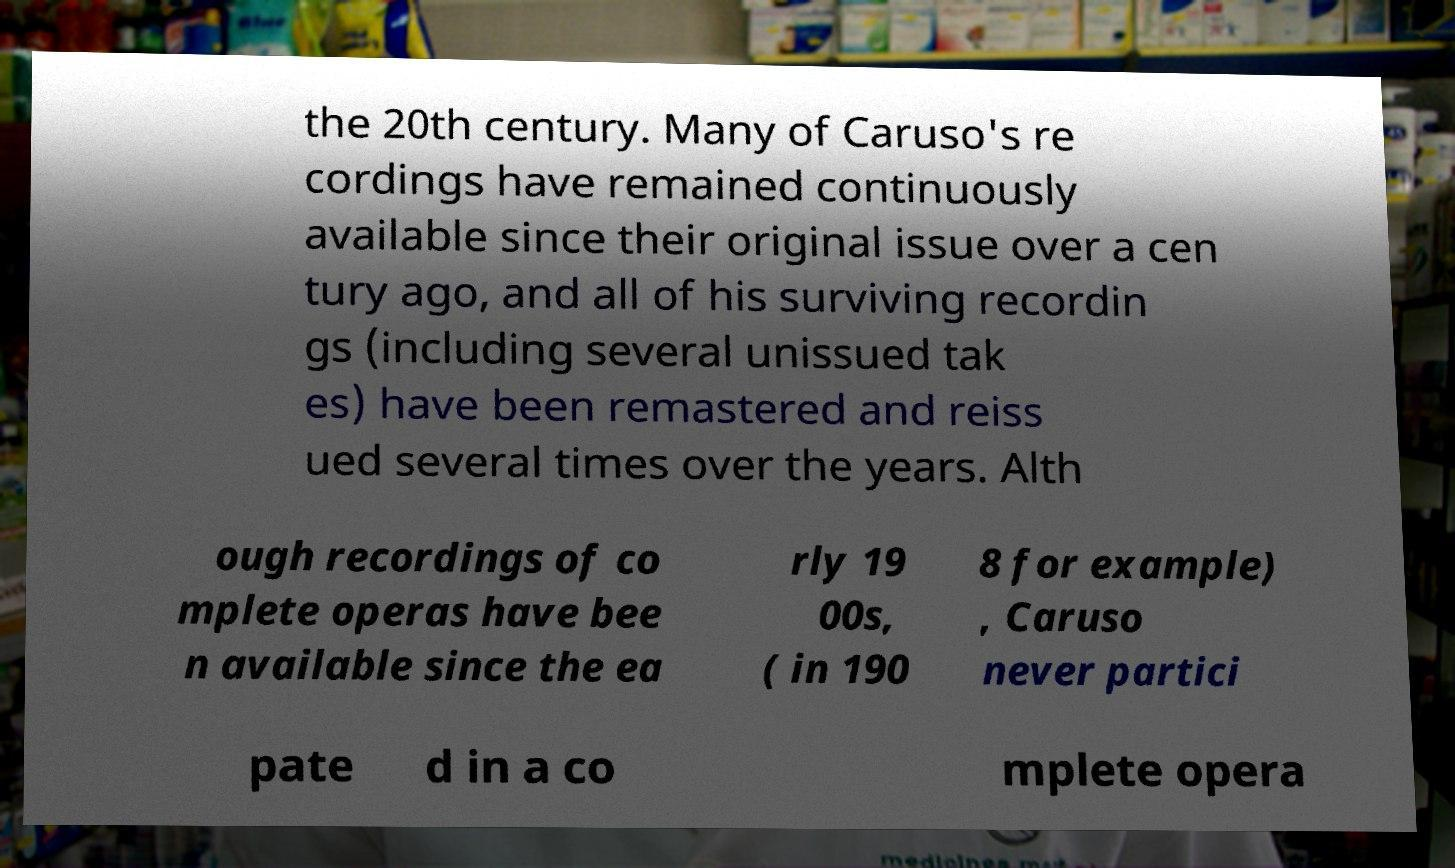There's text embedded in this image that I need extracted. Can you transcribe it verbatim? the 20th century. Many of Caruso's re cordings have remained continuously available since their original issue over a cen tury ago, and all of his surviving recordin gs (including several unissued tak es) have been remastered and reiss ued several times over the years. Alth ough recordings of co mplete operas have bee n available since the ea rly 19 00s, ( in 190 8 for example) , Caruso never partici pate d in a co mplete opera 